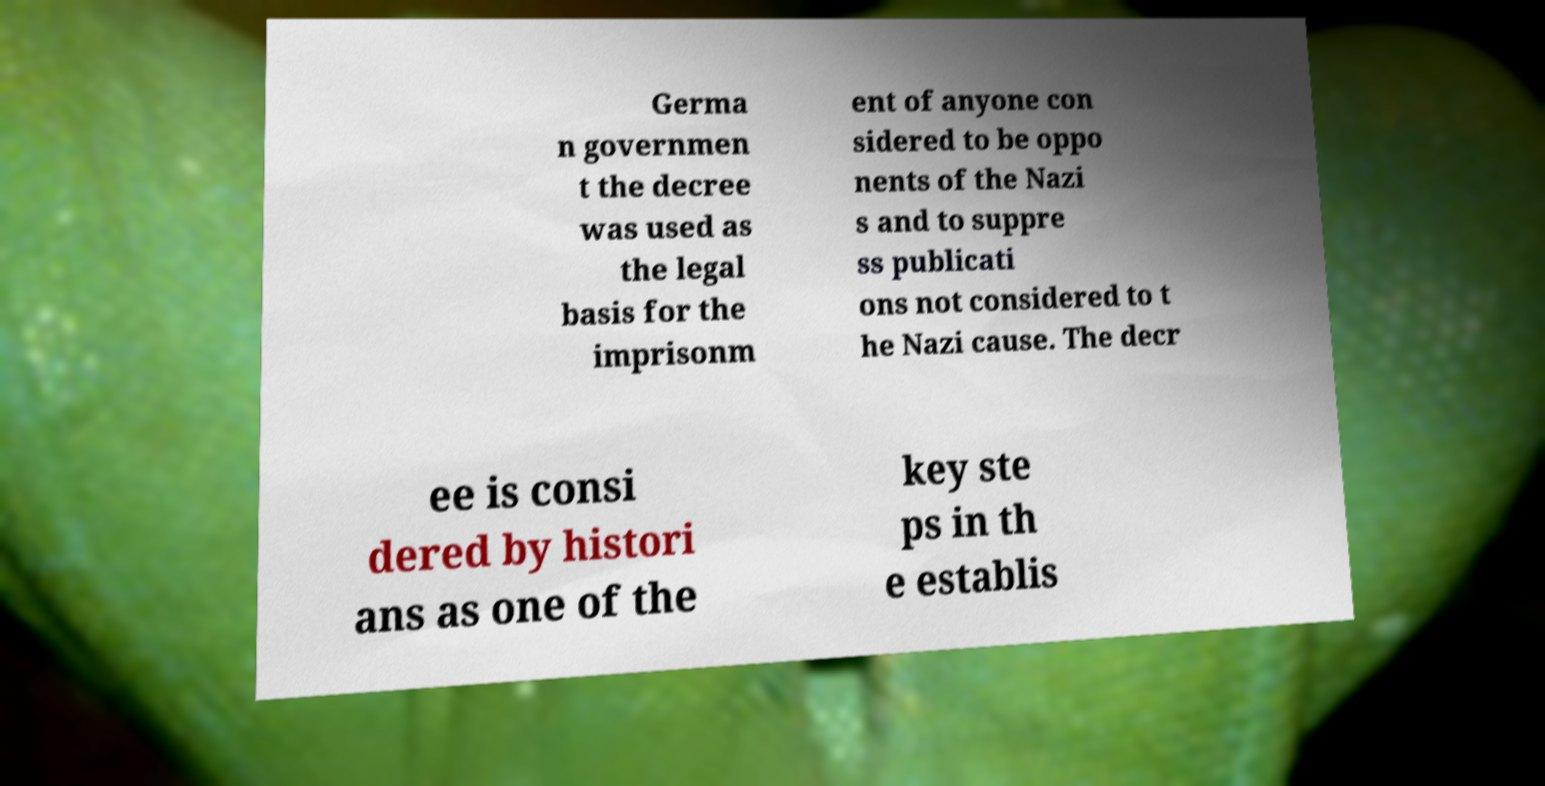Please read and relay the text visible in this image. What does it say? Germa n governmen t the decree was used as the legal basis for the imprisonm ent of anyone con sidered to be oppo nents of the Nazi s and to suppre ss publicati ons not considered to t he Nazi cause. The decr ee is consi dered by histori ans as one of the key ste ps in th e establis 